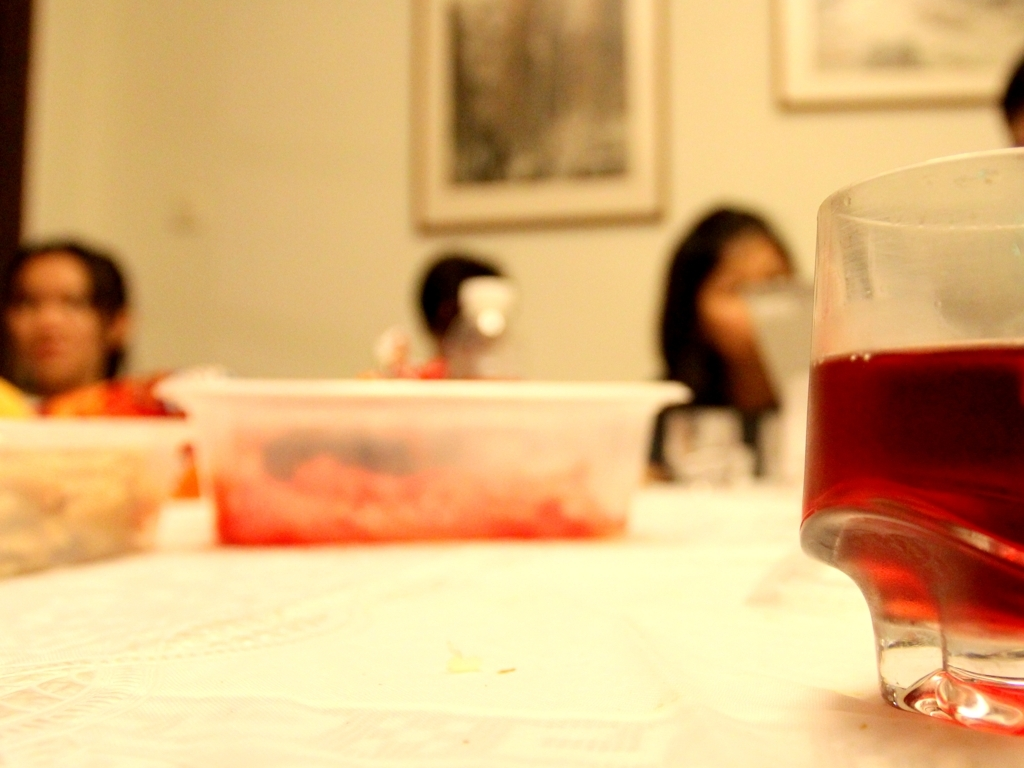Is the image properly focused?
 No 